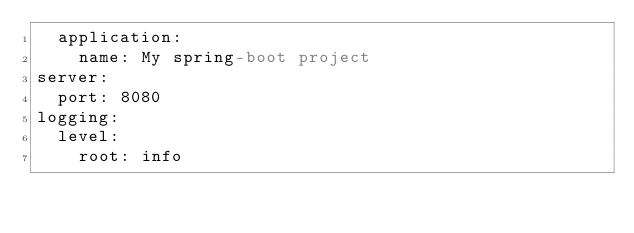Convert code to text. <code><loc_0><loc_0><loc_500><loc_500><_YAML_>  application:
    name: My spring-boot project
server:
  port: 8080
logging:
  level:
    root: info
</code> 